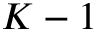Convert formula to latex. <formula><loc_0><loc_0><loc_500><loc_500>K - 1</formula> 